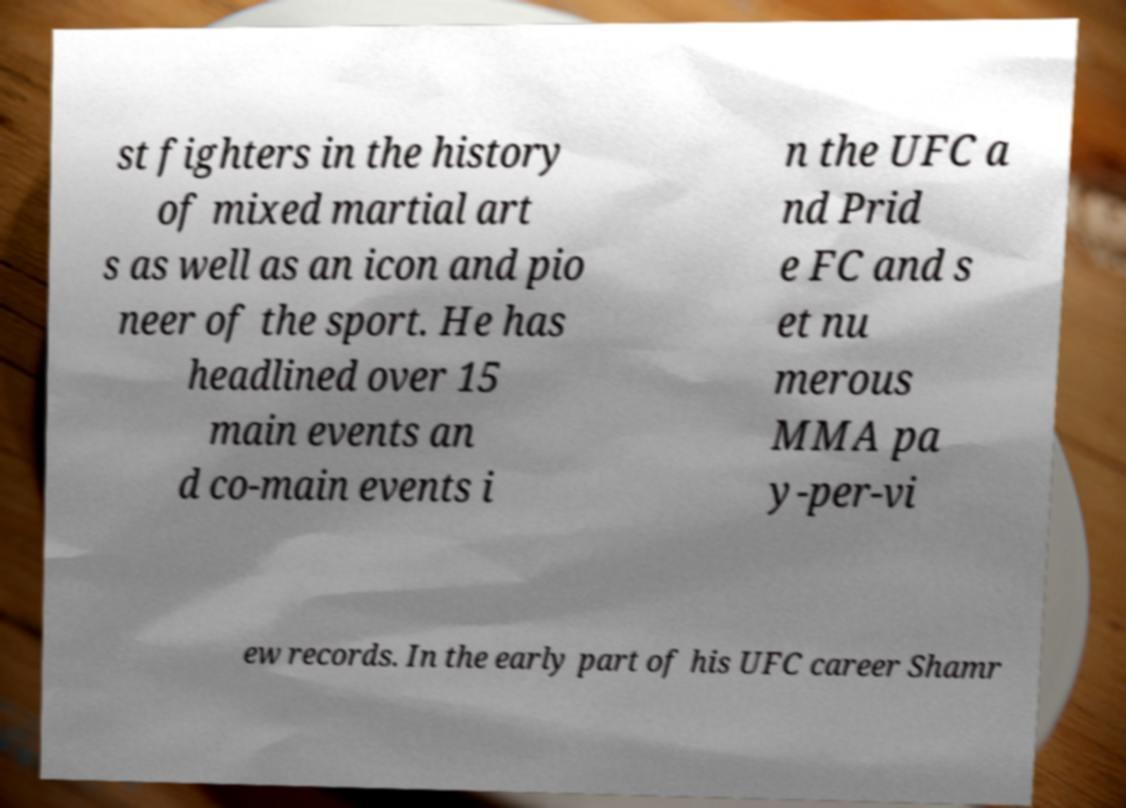Can you accurately transcribe the text from the provided image for me? st fighters in the history of mixed martial art s as well as an icon and pio neer of the sport. He has headlined over 15 main events an d co-main events i n the UFC a nd Prid e FC and s et nu merous MMA pa y-per-vi ew records. In the early part of his UFC career Shamr 